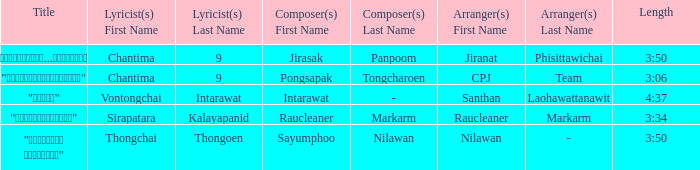Write the full table. {'header': ['Title', 'Lyricist(s) First Name', 'Lyricist(s) Last Name', 'Composer(s) First Name', 'Composer(s) Last Name', 'Arranger(s) First Name', 'Arranger(s) Last Name', 'Length'], 'rows': [['"เรายังรักกัน...ไม่ใช่เหรอ"', 'Chantima', '9', 'Jirasak', 'Panpoom', 'Jiranat', 'Phisittawichai', '3:50'], ['"นางฟ้าตาชั้นเดียว"', 'Chantima', '9', 'Pongsapak', 'Tongcharoen', 'CPJ', 'Team', '3:06'], ['"ขอโทษ"', 'Vontongchai', 'Intarawat', 'Intarawat', '-', 'Santhan', 'Laohawattanawit', '4:37'], ['"แค่อยากให้รู้"', 'Sirapatara', 'Kalayapanid', 'Raucleaner', 'Markarm', 'Raucleaner', 'Markarm', '3:34'], ['"เลือกลืม เลือกจำ"', 'Thongchai', 'Thongoen', 'Sayumphoo', 'Nilawan', 'Nilawan', '-', '3:50']]} Who was the arranger for the song that had a lyricist of Sirapatara Kalayapanid? Raucleaner + Markarm. 